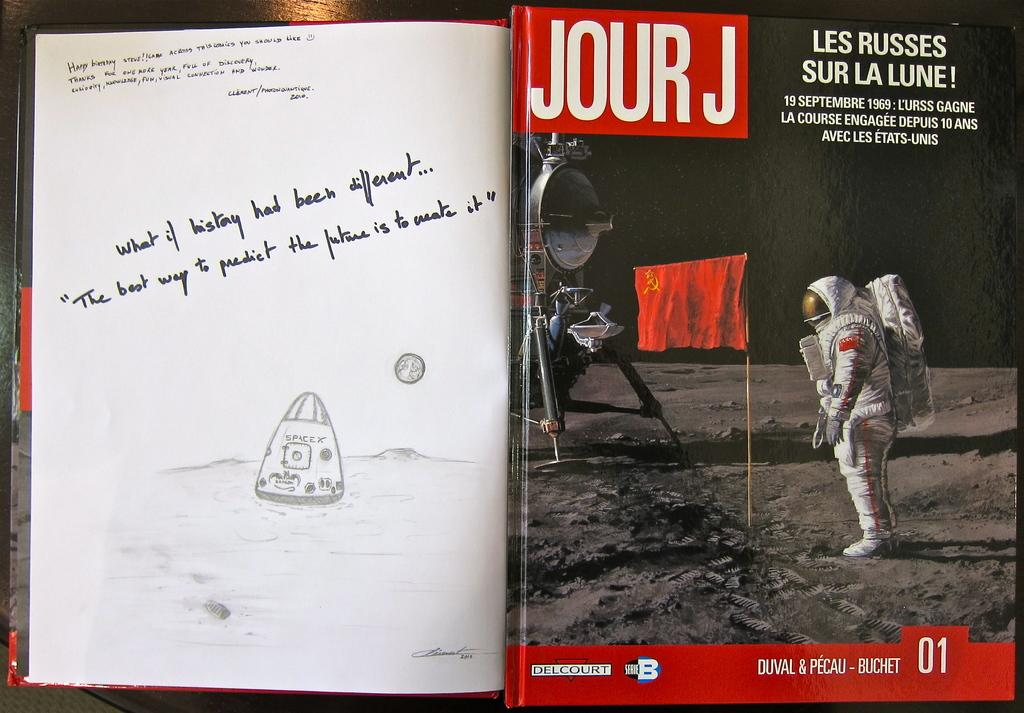Provide a one-sentence caption for the provided image. A book with a motivation note about creating our future and Jour J magazine on top of it. 